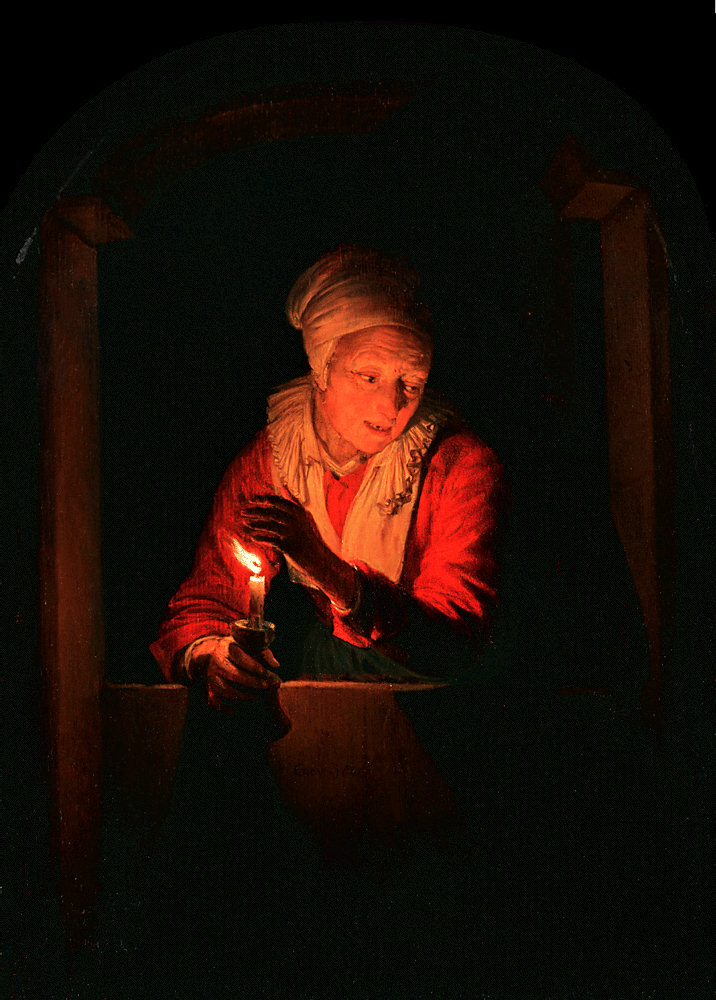What can you tell about the woman's emotional state based on her expression and posture in the painting? The woman in the painting exhibits a serene and contemplative expression, highlighted by the gentle illumination. Her slightly tilted head and the soft gaze directed towards the candle suggest a deep engagement or meditation. This posture and expression together convey a sense of tranquility and reflection, possibly indicating a moment of personal significance or introspection. 